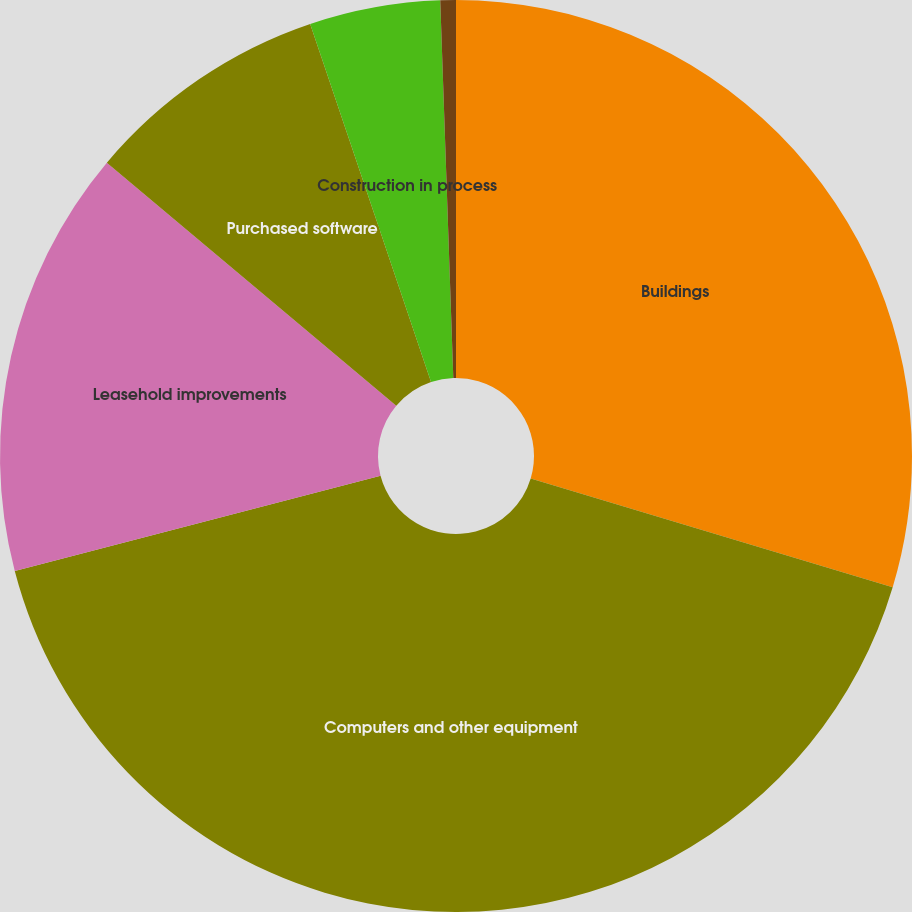Convert chart to OTSL. <chart><loc_0><loc_0><loc_500><loc_500><pie_chart><fcel>Buildings<fcel>Computers and other equipment<fcel>Leasehold improvements<fcel>Purchased software<fcel>Construction in process<fcel>Land and other non-depreciable<nl><fcel>29.65%<fcel>41.29%<fcel>15.18%<fcel>8.7%<fcel>4.63%<fcel>0.55%<nl></chart> 